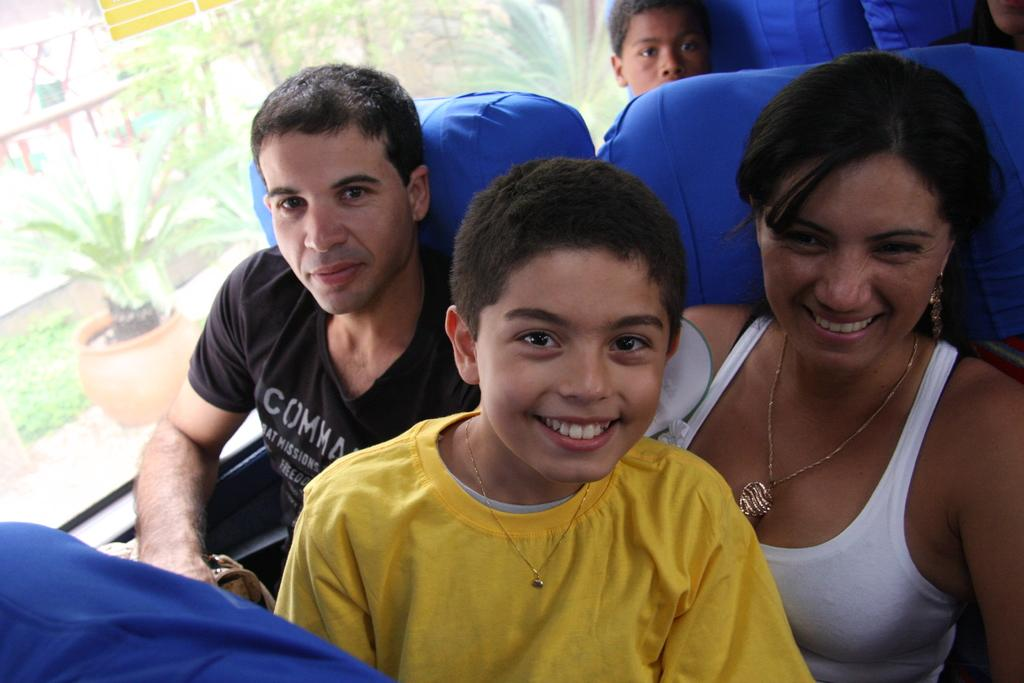What is the main subject of the image? The main subject of the image is a person sitting in the bus. Where is the bus located in the image? The bus is in the center of the image. What can be seen in the background of the image? There are plants and fencing in the background of the image. How many visitors are present in the image? There is no mention of visitors in the image; it only shows a person sitting in the bus. What type of light source is illuminating the scene in the image? There is no specific light source mentioned in the image; it simply shows a person sitting in the bus with a background of plants and fencing. 